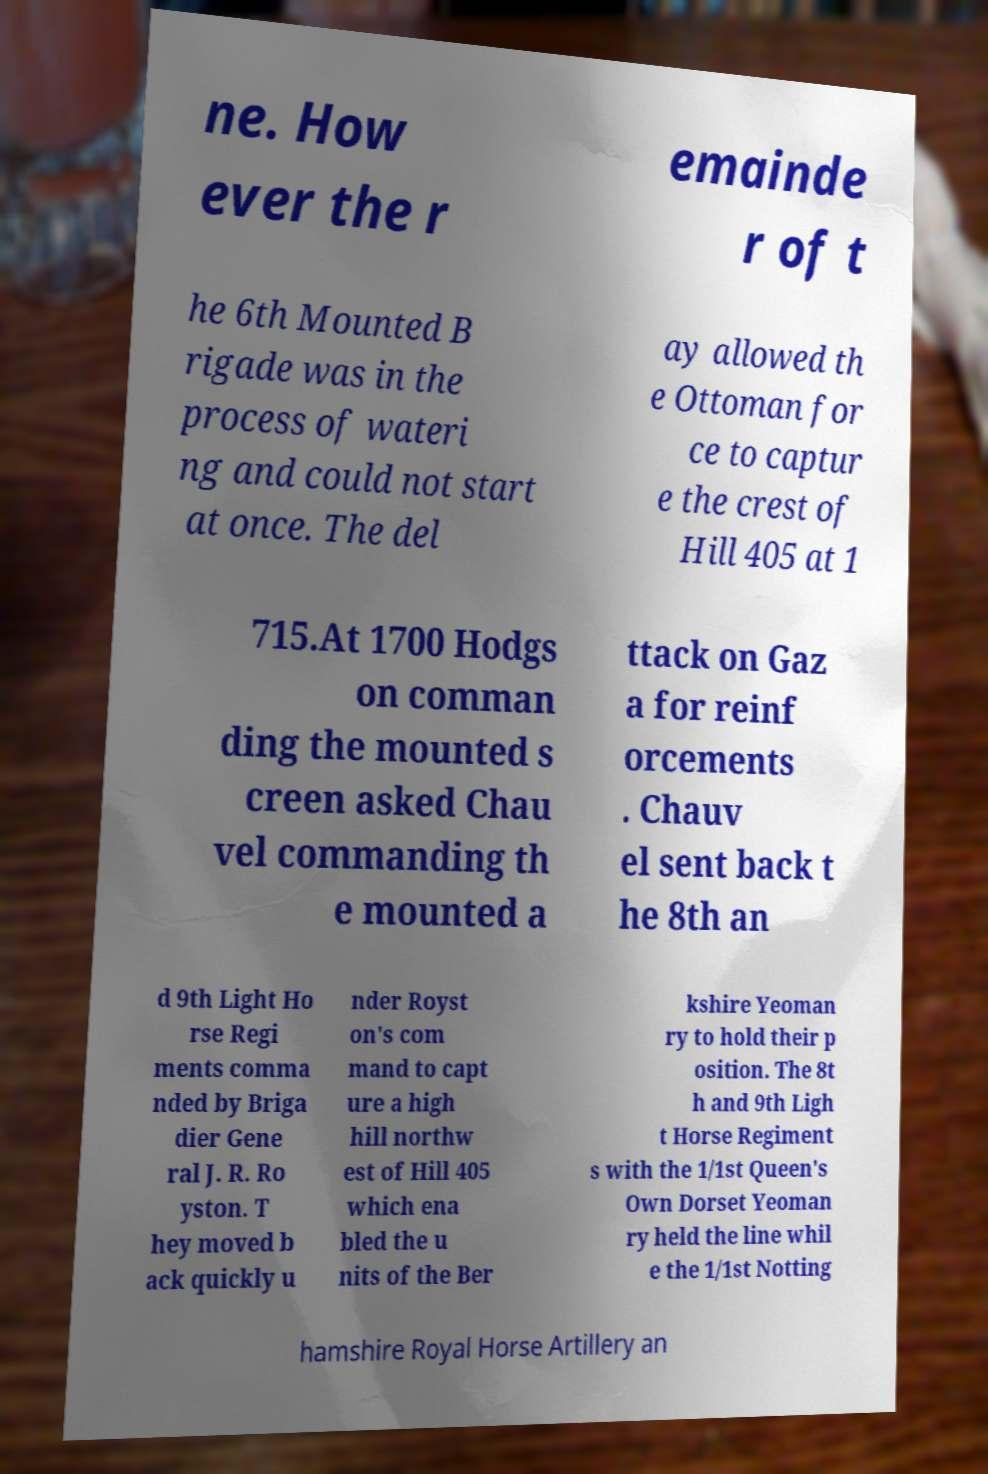There's text embedded in this image that I need extracted. Can you transcribe it verbatim? ne. How ever the r emainde r of t he 6th Mounted B rigade was in the process of wateri ng and could not start at once. The del ay allowed th e Ottoman for ce to captur e the crest of Hill 405 at 1 715.At 1700 Hodgs on comman ding the mounted s creen asked Chau vel commanding th e mounted a ttack on Gaz a for reinf orcements . Chauv el sent back t he 8th an d 9th Light Ho rse Regi ments comma nded by Briga dier Gene ral J. R. Ro yston. T hey moved b ack quickly u nder Royst on's com mand to capt ure a high hill northw est of Hill 405 which ena bled the u nits of the Ber kshire Yeoman ry to hold their p osition. The 8t h and 9th Ligh t Horse Regiment s with the 1/1st Queen's Own Dorset Yeoman ry held the line whil e the 1/1st Notting hamshire Royal Horse Artillery an 